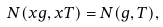<formula> <loc_0><loc_0><loc_500><loc_500>N ( x g , x T ) = N ( g , T ) ,</formula> 